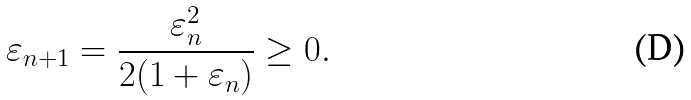Convert formula to latex. <formula><loc_0><loc_0><loc_500><loc_500>\varepsilon _ { n + 1 } = { \frac { \varepsilon _ { n } ^ { 2 } } { 2 ( 1 + \varepsilon _ { n } ) } } \geq 0 .</formula> 